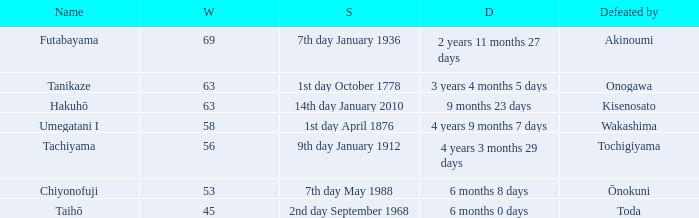How many wins were held before being defeated by toda? 1.0. 